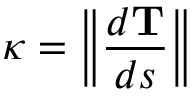Convert formula to latex. <formula><loc_0><loc_0><loc_500><loc_500>\kappa = \left \| { \frac { d T } { d s } } \right \|</formula> 